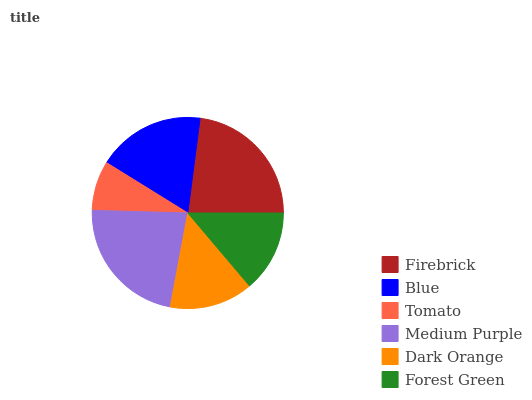Is Tomato the minimum?
Answer yes or no. Yes. Is Firebrick the maximum?
Answer yes or no. Yes. Is Blue the minimum?
Answer yes or no. No. Is Blue the maximum?
Answer yes or no. No. Is Firebrick greater than Blue?
Answer yes or no. Yes. Is Blue less than Firebrick?
Answer yes or no. Yes. Is Blue greater than Firebrick?
Answer yes or no. No. Is Firebrick less than Blue?
Answer yes or no. No. Is Blue the high median?
Answer yes or no. Yes. Is Dark Orange the low median?
Answer yes or no. Yes. Is Medium Purple the high median?
Answer yes or no. No. Is Medium Purple the low median?
Answer yes or no. No. 